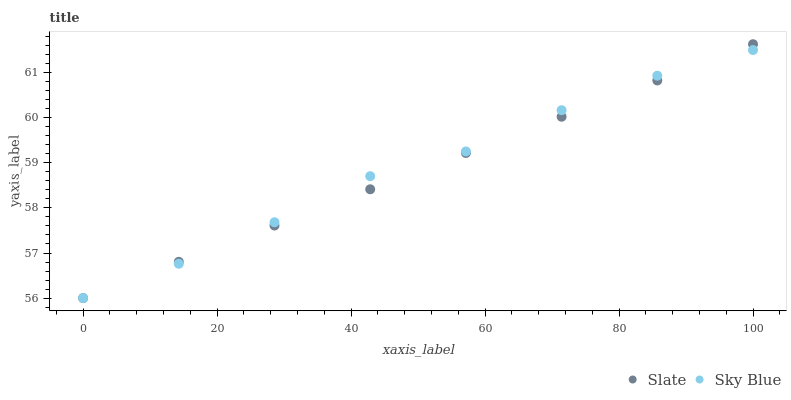Does Slate have the minimum area under the curve?
Answer yes or no. Yes. Does Sky Blue have the maximum area under the curve?
Answer yes or no. Yes. Does Slate have the maximum area under the curve?
Answer yes or no. No. Is Slate the smoothest?
Answer yes or no. Yes. Is Sky Blue the roughest?
Answer yes or no. Yes. Is Slate the roughest?
Answer yes or no. No. Does Sky Blue have the lowest value?
Answer yes or no. Yes. Does Slate have the highest value?
Answer yes or no. Yes. Does Sky Blue intersect Slate?
Answer yes or no. Yes. Is Sky Blue less than Slate?
Answer yes or no. No. Is Sky Blue greater than Slate?
Answer yes or no. No. 